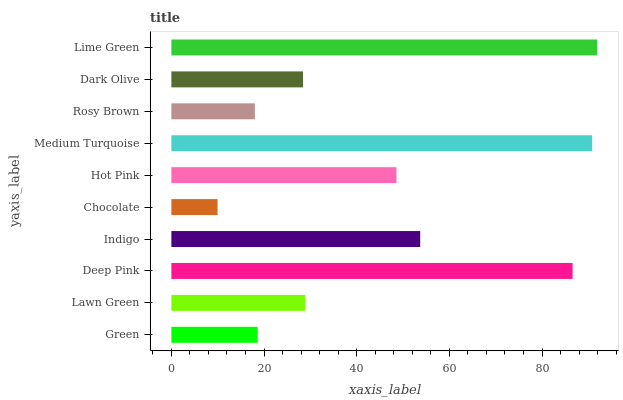Is Chocolate the minimum?
Answer yes or no. Yes. Is Lime Green the maximum?
Answer yes or no. Yes. Is Lawn Green the minimum?
Answer yes or no. No. Is Lawn Green the maximum?
Answer yes or no. No. Is Lawn Green greater than Green?
Answer yes or no. Yes. Is Green less than Lawn Green?
Answer yes or no. Yes. Is Green greater than Lawn Green?
Answer yes or no. No. Is Lawn Green less than Green?
Answer yes or no. No. Is Hot Pink the high median?
Answer yes or no. Yes. Is Lawn Green the low median?
Answer yes or no. Yes. Is Rosy Brown the high median?
Answer yes or no. No. Is Dark Olive the low median?
Answer yes or no. No. 